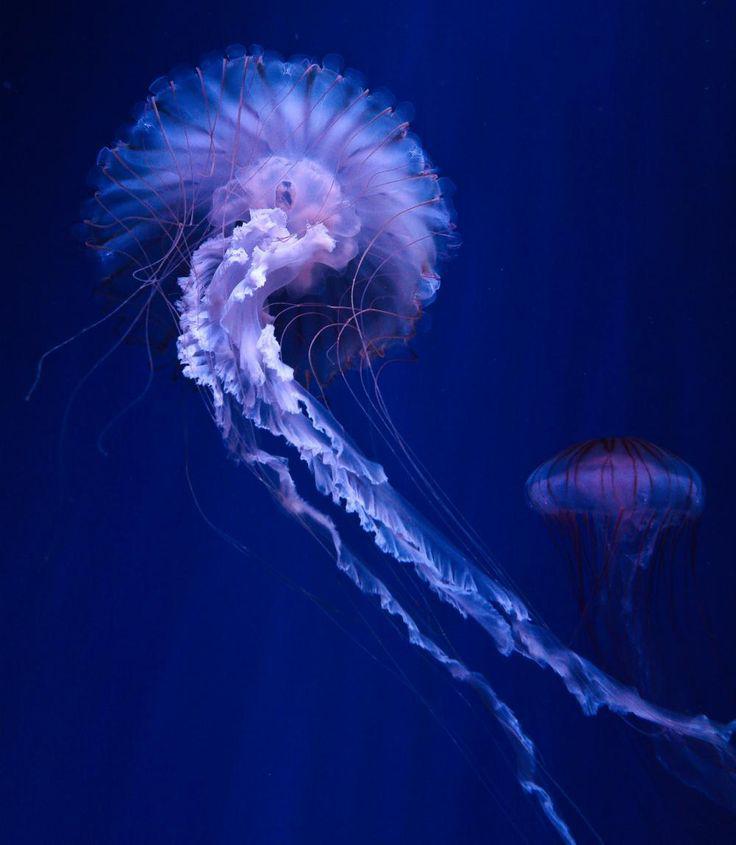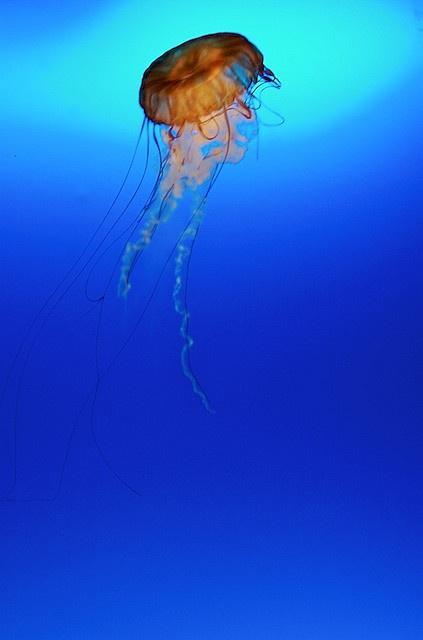The first image is the image on the left, the second image is the image on the right. Given the left and right images, does the statement "Two jellyfish are visible in the left image." hold true? Answer yes or no. Yes. 